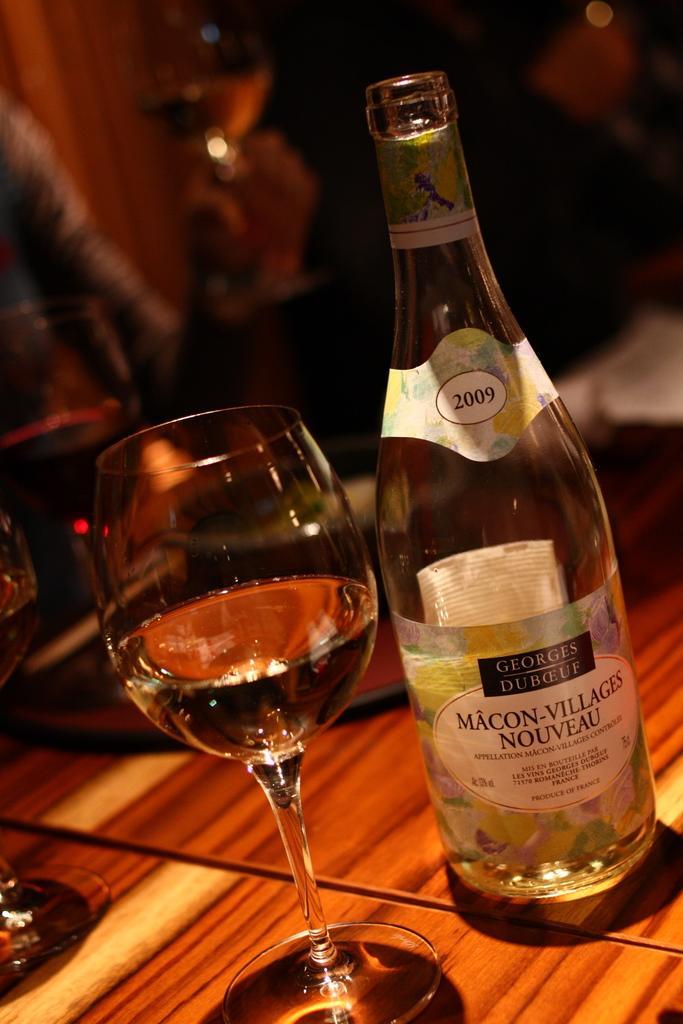Describe this image in one or two sentences. On the table, we can see the wine bottle on the right side and the glass on the right side and it consists of wine. 